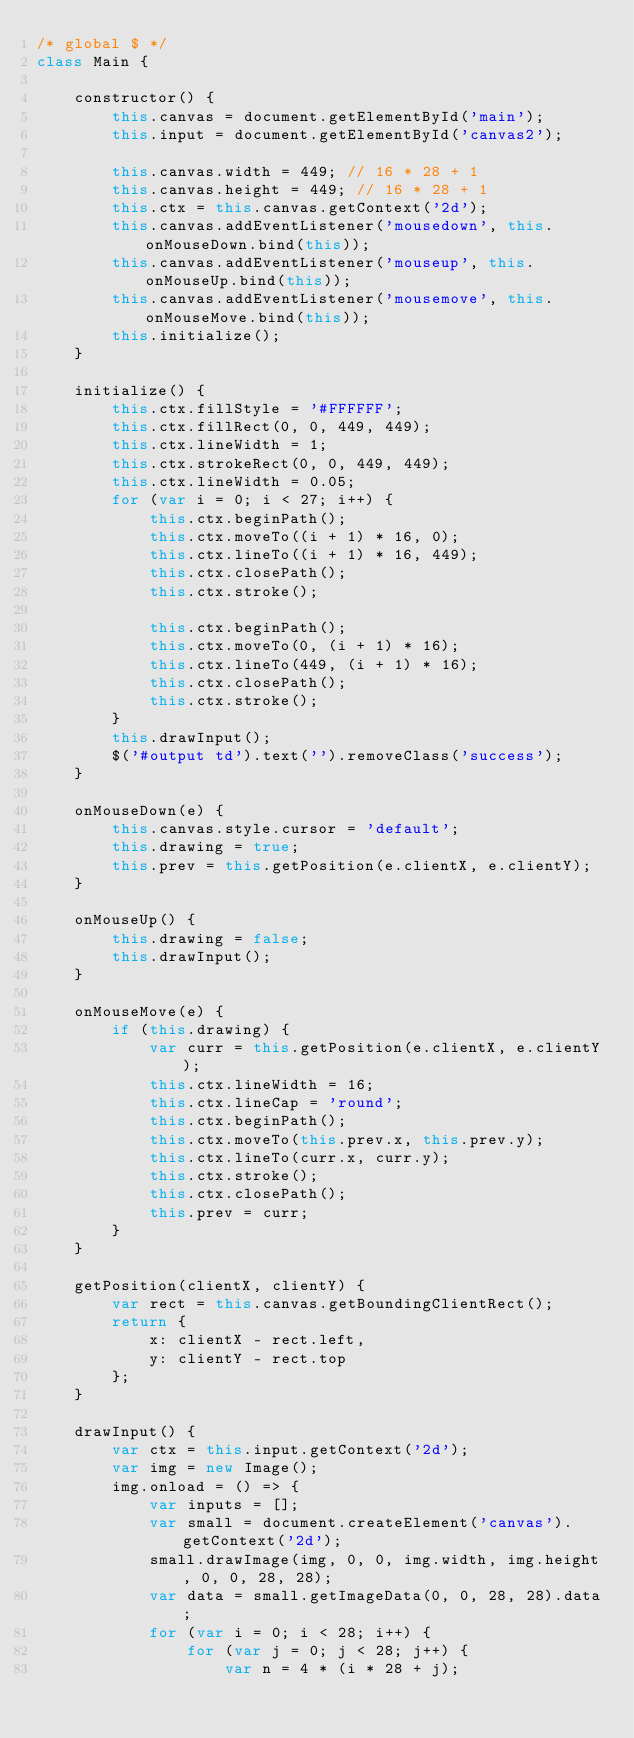<code> <loc_0><loc_0><loc_500><loc_500><_JavaScript_>/* global $ */
class Main {

    constructor() {
        this.canvas = document.getElementById('main');
        this.input = document.getElementById('canvas2');

        this.canvas.width = 449; // 16 * 28 + 1
        this.canvas.height = 449; // 16 * 28 + 1
        this.ctx = this.canvas.getContext('2d');
        this.canvas.addEventListener('mousedown', this.onMouseDown.bind(this));
        this.canvas.addEventListener('mouseup', this.onMouseUp.bind(this));
        this.canvas.addEventListener('mousemove', this.onMouseMove.bind(this));
        this.initialize();
    }

    initialize() {
        this.ctx.fillStyle = '#FFFFFF';
        this.ctx.fillRect(0, 0, 449, 449);
        this.ctx.lineWidth = 1;
        this.ctx.strokeRect(0, 0, 449, 449);
        this.ctx.lineWidth = 0.05;
        for (var i = 0; i < 27; i++) {
            this.ctx.beginPath();
            this.ctx.moveTo((i + 1) * 16, 0);
            this.ctx.lineTo((i + 1) * 16, 449);
            this.ctx.closePath();
            this.ctx.stroke();

            this.ctx.beginPath();
            this.ctx.moveTo(0, (i + 1) * 16);
            this.ctx.lineTo(449, (i + 1) * 16);
            this.ctx.closePath();
            this.ctx.stroke();
        }
        this.drawInput();
        $('#output td').text('').removeClass('success');
    }

    onMouseDown(e) {
        this.canvas.style.cursor = 'default';
        this.drawing = true;
        this.prev = this.getPosition(e.clientX, e.clientY);
    }

    onMouseUp() {
        this.drawing = false;
        this.drawInput();
    }

    onMouseMove(e) {
        if (this.drawing) {
            var curr = this.getPosition(e.clientX, e.clientY);
            this.ctx.lineWidth = 16;
            this.ctx.lineCap = 'round';
            this.ctx.beginPath();
            this.ctx.moveTo(this.prev.x, this.prev.y);
            this.ctx.lineTo(curr.x, curr.y);
            this.ctx.stroke();
            this.ctx.closePath();
            this.prev = curr;
        }
    }

    getPosition(clientX, clientY) {
        var rect = this.canvas.getBoundingClientRect();
        return {
            x: clientX - rect.left,
            y: clientY - rect.top
        };
    }

    drawInput() {
        var ctx = this.input.getContext('2d');
        var img = new Image();
        img.onload = () => {
            var inputs = [];
            var small = document.createElement('canvas').getContext('2d');
            small.drawImage(img, 0, 0, img.width, img.height, 0, 0, 28, 28);
            var data = small.getImageData(0, 0, 28, 28).data;
            for (var i = 0; i < 28; i++) {
                for (var j = 0; j < 28; j++) {
                    var n = 4 * (i * 28 + j);</code> 